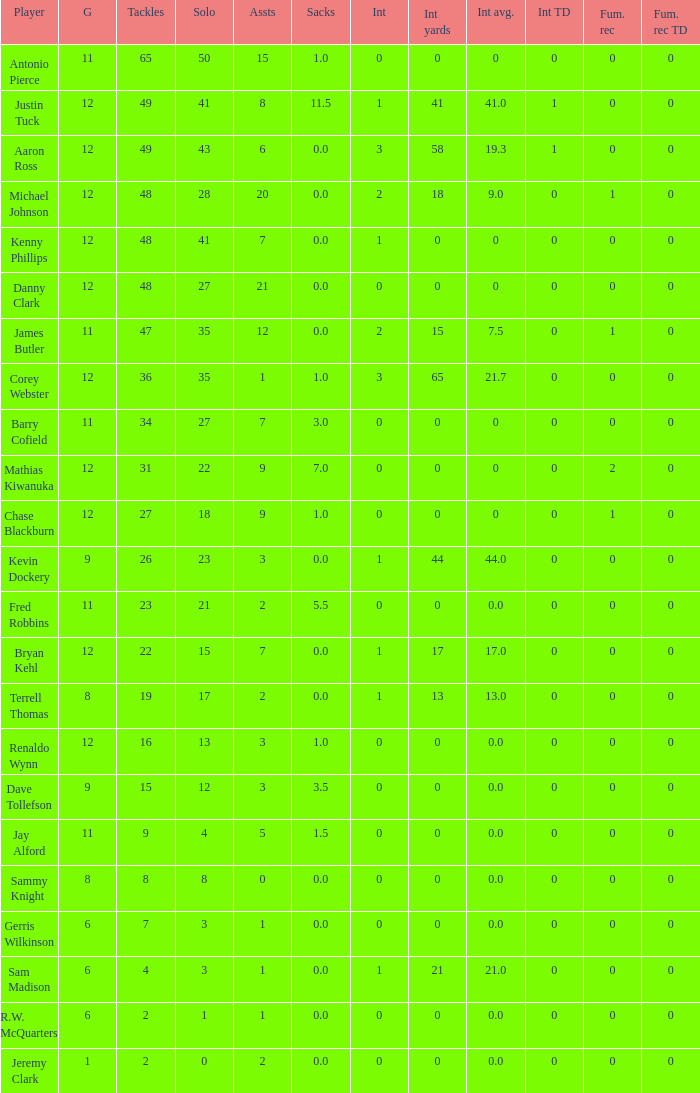What is the minimum number of integer yards? 0.0. Could you parse the entire table? {'header': ['Player', 'G', 'Tackles', 'Solo', 'Assts', 'Sacks', 'Int', 'Int yards', 'Int avg.', 'Int TD', 'Fum. rec', 'Fum. rec TD'], 'rows': [['Antonio Pierce', '11', '65', '50', '15', '1.0', '0', '0', '0', '0', '0', '0'], ['Justin Tuck', '12', '49', '41', '8', '11.5', '1', '41', '41.0', '1', '0', '0'], ['Aaron Ross', '12', '49', '43', '6', '0.0', '3', '58', '19.3', '1', '0', '0'], ['Michael Johnson', '12', '48', '28', '20', '0.0', '2', '18', '9.0', '0', '1', '0'], ['Kenny Phillips', '12', '48', '41', '7', '0.0', '1', '0', '0', '0', '0', '0'], ['Danny Clark', '12', '48', '27', '21', '0.0', '0', '0', '0', '0', '0', '0'], ['James Butler', '11', '47', '35', '12', '0.0', '2', '15', '7.5', '0', '1', '0'], ['Corey Webster', '12', '36', '35', '1', '1.0', '3', '65', '21.7', '0', '0', '0'], ['Barry Cofield', '11', '34', '27', '7', '3.0', '0', '0', '0', '0', '0', '0'], ['Mathias Kiwanuka', '12', '31', '22', '9', '7.0', '0', '0', '0', '0', '2', '0'], ['Chase Blackburn', '12', '27', '18', '9', '1.0', '0', '0', '0', '0', '1', '0'], ['Kevin Dockery', '9', '26', '23', '3', '0.0', '1', '44', '44.0', '0', '0', '0'], ['Fred Robbins', '11', '23', '21', '2', '5.5', '0', '0', '0.0', '0', '0', '0'], ['Bryan Kehl', '12', '22', '15', '7', '0.0', '1', '17', '17.0', '0', '0', '0'], ['Terrell Thomas', '8', '19', '17', '2', '0.0', '1', '13', '13.0', '0', '0', '0'], ['Renaldo Wynn', '12', '16', '13', '3', '1.0', '0', '0', '0.0', '0', '0', '0'], ['Dave Tollefson', '9', '15', '12', '3', '3.5', '0', '0', '0.0', '0', '0', '0'], ['Jay Alford', '11', '9', '4', '5', '1.5', '0', '0', '0.0', '0', '0', '0'], ['Sammy Knight', '8', '8', '8', '0', '0.0', '0', '0', '0.0', '0', '0', '0'], ['Gerris Wilkinson', '6', '7', '3', '1', '0.0', '0', '0', '0.0', '0', '0', '0'], ['Sam Madison', '6', '4', '3', '1', '0.0', '1', '21', '21.0', '0', '0', '0'], ['R.W. McQuarters', '6', '2', '1', '1', '0.0', '0', '0', '0.0', '0', '0', '0'], ['Jeremy Clark', '1', '2', '0', '2', '0.0', '0', '0', '0.0', '0', '0', '0']]} 